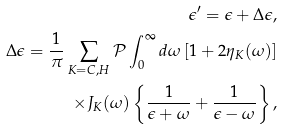<formula> <loc_0><loc_0><loc_500><loc_500>\epsilon ^ { \prime } = \epsilon + \Delta \epsilon , \\ \Delta \epsilon = \frac { 1 } { \pi } \sum _ { K = C , H } \mathcal { P } \int ^ { \infty } _ { 0 } d \omega \left [ 1 + 2 \eta _ { K } ( \omega ) \right ] \\ \times J _ { K } ( \omega ) \left \{ \frac { 1 } { \epsilon + \omega } + \frac { 1 } { \epsilon - \omega } \right \} ,</formula> 